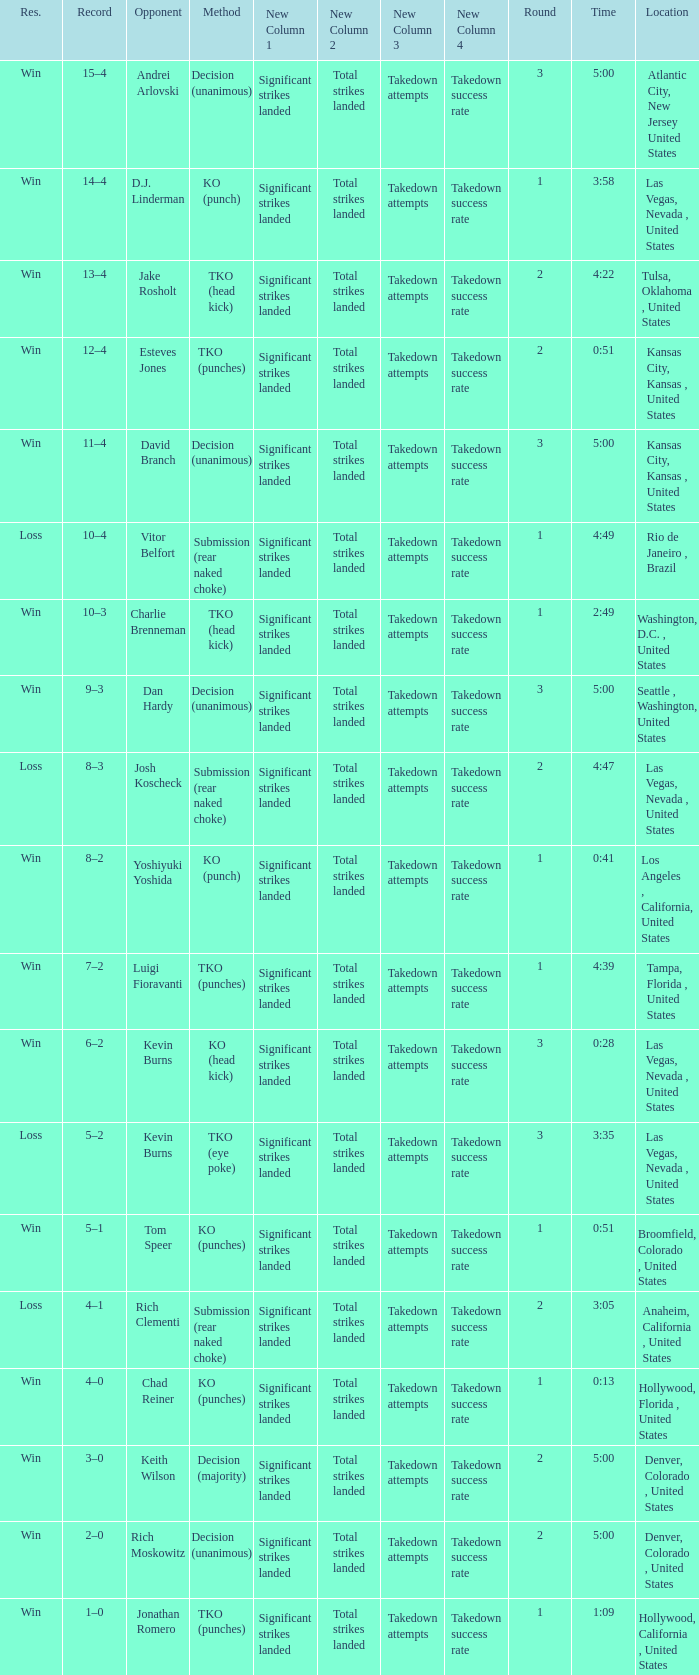What is the result for rounds under 2 against D.J. Linderman? Win. 